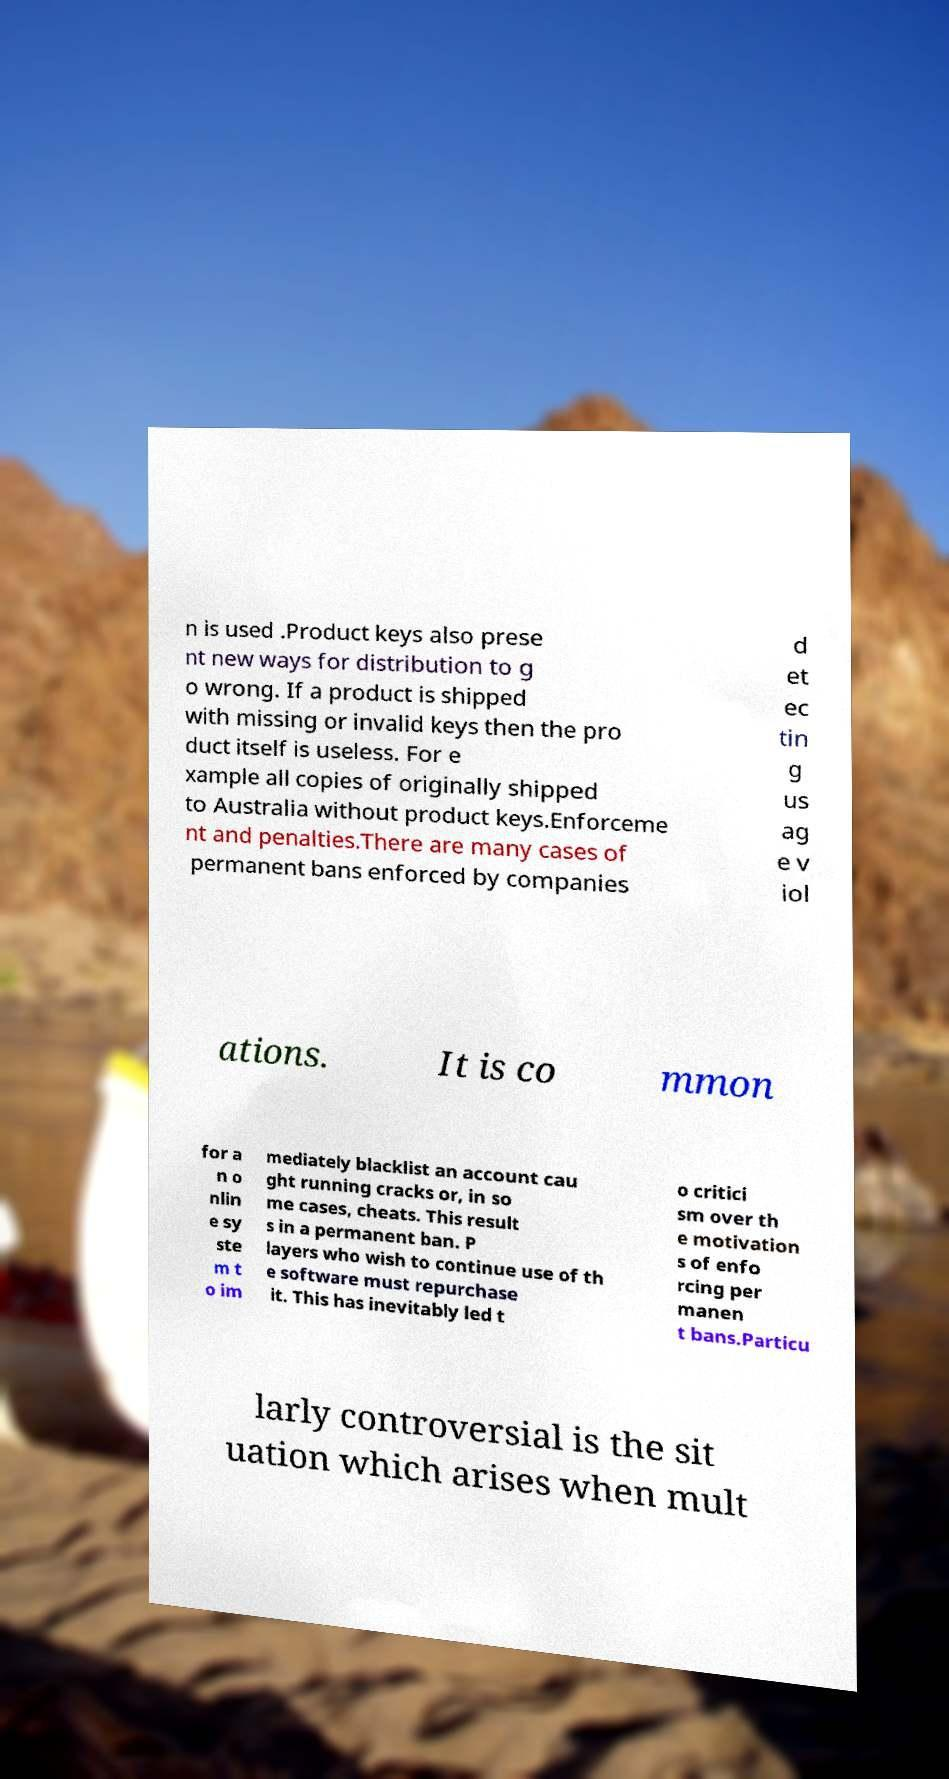What messages or text are displayed in this image? I need them in a readable, typed format. n is used .Product keys also prese nt new ways for distribution to g o wrong. If a product is shipped with missing or invalid keys then the pro duct itself is useless. For e xample all copies of originally shipped to Australia without product keys.Enforceme nt and penalties.There are many cases of permanent bans enforced by companies d et ec tin g us ag e v iol ations. It is co mmon for a n o nlin e sy ste m t o im mediately blacklist an account cau ght running cracks or, in so me cases, cheats. This result s in a permanent ban. P layers who wish to continue use of th e software must repurchase it. This has inevitably led t o critici sm over th e motivation s of enfo rcing per manen t bans.Particu larly controversial is the sit uation which arises when mult 